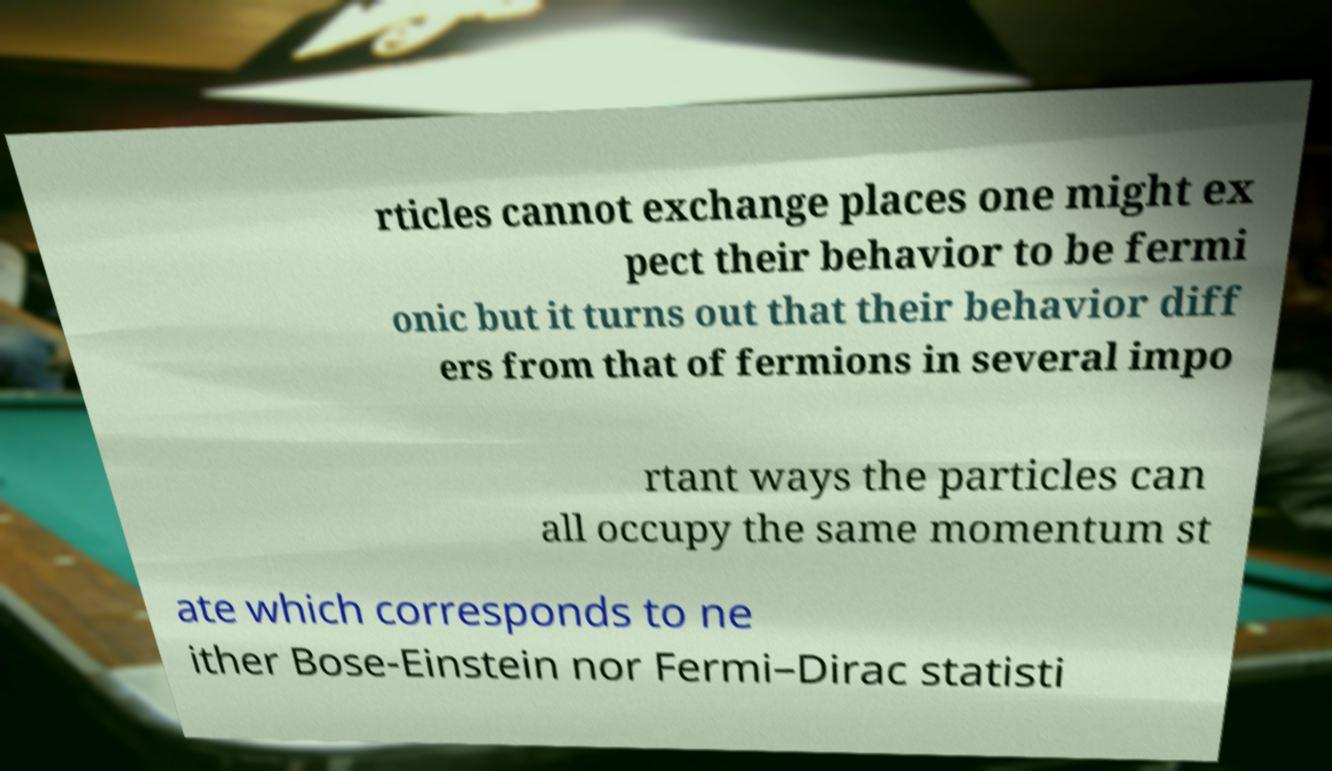There's text embedded in this image that I need extracted. Can you transcribe it verbatim? rticles cannot exchange places one might ex pect their behavior to be fermi onic but it turns out that their behavior diff ers from that of fermions in several impo rtant ways the particles can all occupy the same momentum st ate which corresponds to ne ither Bose-Einstein nor Fermi–Dirac statisti 